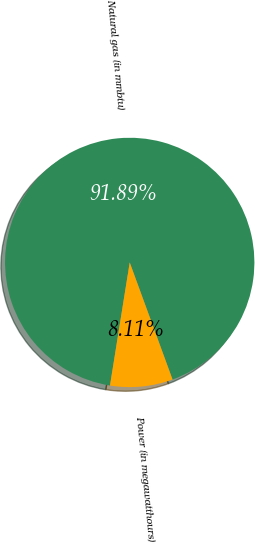<chart> <loc_0><loc_0><loc_500><loc_500><pie_chart><fcel>Natural gas (in mmbtu)<fcel>Power (in megawatthours)<nl><fcel>91.89%<fcel>8.11%<nl></chart> 